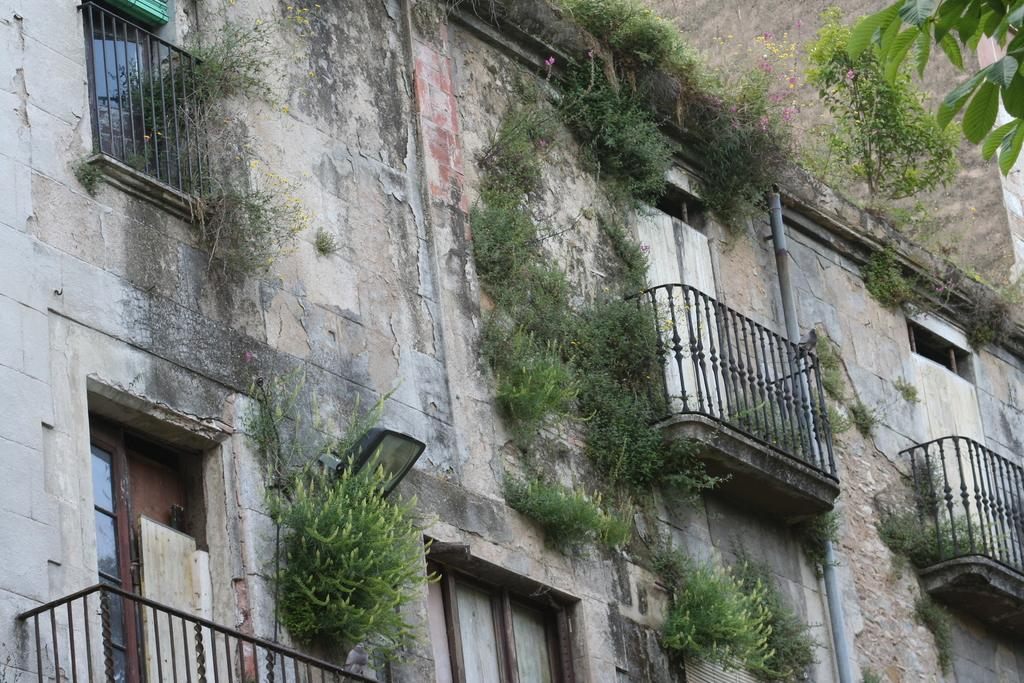What type of structure is present in the image? There is a building in the image. What can be found inside the building? The building contains plants. Can you describe any specific features of the building? There is a pipe visible in the building, and it has windows. What type of vegetation is present in the image? Shrubs, flowers, and leaves of a tree are visible in the image. What is the material of the wall on the right side of the image? There is a brick wall in the image. What type of oil is being used to water the plants in the image? There is no mention of oil being used to water the plants in the image. The plants are likely being watered with water, as it is the most common and practical method for watering plants. 